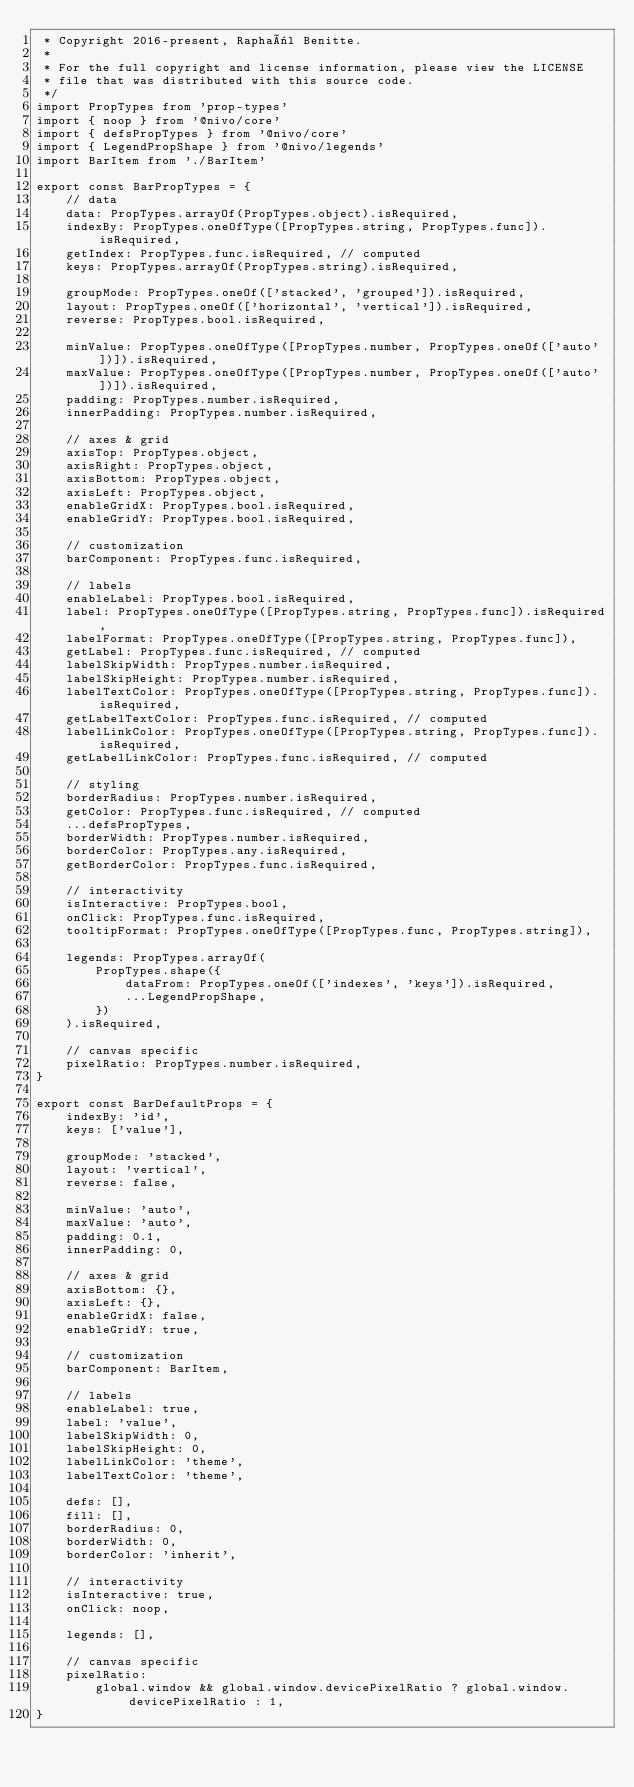<code> <loc_0><loc_0><loc_500><loc_500><_JavaScript_> * Copyright 2016-present, Raphaël Benitte.
 *
 * For the full copyright and license information, please view the LICENSE
 * file that was distributed with this source code.
 */
import PropTypes from 'prop-types'
import { noop } from '@nivo/core'
import { defsPropTypes } from '@nivo/core'
import { LegendPropShape } from '@nivo/legends'
import BarItem from './BarItem'

export const BarPropTypes = {
    // data
    data: PropTypes.arrayOf(PropTypes.object).isRequired,
    indexBy: PropTypes.oneOfType([PropTypes.string, PropTypes.func]).isRequired,
    getIndex: PropTypes.func.isRequired, // computed
    keys: PropTypes.arrayOf(PropTypes.string).isRequired,

    groupMode: PropTypes.oneOf(['stacked', 'grouped']).isRequired,
    layout: PropTypes.oneOf(['horizontal', 'vertical']).isRequired,
    reverse: PropTypes.bool.isRequired,

    minValue: PropTypes.oneOfType([PropTypes.number, PropTypes.oneOf(['auto'])]).isRequired,
    maxValue: PropTypes.oneOfType([PropTypes.number, PropTypes.oneOf(['auto'])]).isRequired,
    padding: PropTypes.number.isRequired,
    innerPadding: PropTypes.number.isRequired,

    // axes & grid
    axisTop: PropTypes.object,
    axisRight: PropTypes.object,
    axisBottom: PropTypes.object,
    axisLeft: PropTypes.object,
    enableGridX: PropTypes.bool.isRequired,
    enableGridY: PropTypes.bool.isRequired,

    // customization
    barComponent: PropTypes.func.isRequired,

    // labels
    enableLabel: PropTypes.bool.isRequired,
    label: PropTypes.oneOfType([PropTypes.string, PropTypes.func]).isRequired,
    labelFormat: PropTypes.oneOfType([PropTypes.string, PropTypes.func]),
    getLabel: PropTypes.func.isRequired, // computed
    labelSkipWidth: PropTypes.number.isRequired,
    labelSkipHeight: PropTypes.number.isRequired,
    labelTextColor: PropTypes.oneOfType([PropTypes.string, PropTypes.func]).isRequired,
    getLabelTextColor: PropTypes.func.isRequired, // computed
    labelLinkColor: PropTypes.oneOfType([PropTypes.string, PropTypes.func]).isRequired,
    getLabelLinkColor: PropTypes.func.isRequired, // computed

    // styling
    borderRadius: PropTypes.number.isRequired,
    getColor: PropTypes.func.isRequired, // computed
    ...defsPropTypes,
    borderWidth: PropTypes.number.isRequired,
    borderColor: PropTypes.any.isRequired,
    getBorderColor: PropTypes.func.isRequired,

    // interactivity
    isInteractive: PropTypes.bool,
    onClick: PropTypes.func.isRequired,
    tooltipFormat: PropTypes.oneOfType([PropTypes.func, PropTypes.string]),

    legends: PropTypes.arrayOf(
        PropTypes.shape({
            dataFrom: PropTypes.oneOf(['indexes', 'keys']).isRequired,
            ...LegendPropShape,
        })
    ).isRequired,

    // canvas specific
    pixelRatio: PropTypes.number.isRequired,
}

export const BarDefaultProps = {
    indexBy: 'id',
    keys: ['value'],

    groupMode: 'stacked',
    layout: 'vertical',
    reverse: false,

    minValue: 'auto',
    maxValue: 'auto',
    padding: 0.1,
    innerPadding: 0,

    // axes & grid
    axisBottom: {},
    axisLeft: {},
    enableGridX: false,
    enableGridY: true,

    // customization
    barComponent: BarItem,

    // labels
    enableLabel: true,
    label: 'value',
    labelSkipWidth: 0,
    labelSkipHeight: 0,
    labelLinkColor: 'theme',
    labelTextColor: 'theme',

    defs: [],
    fill: [],
    borderRadius: 0,
    borderWidth: 0,
    borderColor: 'inherit',

    // interactivity
    isInteractive: true,
    onClick: noop,

    legends: [],

    // canvas specific
    pixelRatio:
        global.window && global.window.devicePixelRatio ? global.window.devicePixelRatio : 1,
}
</code> 